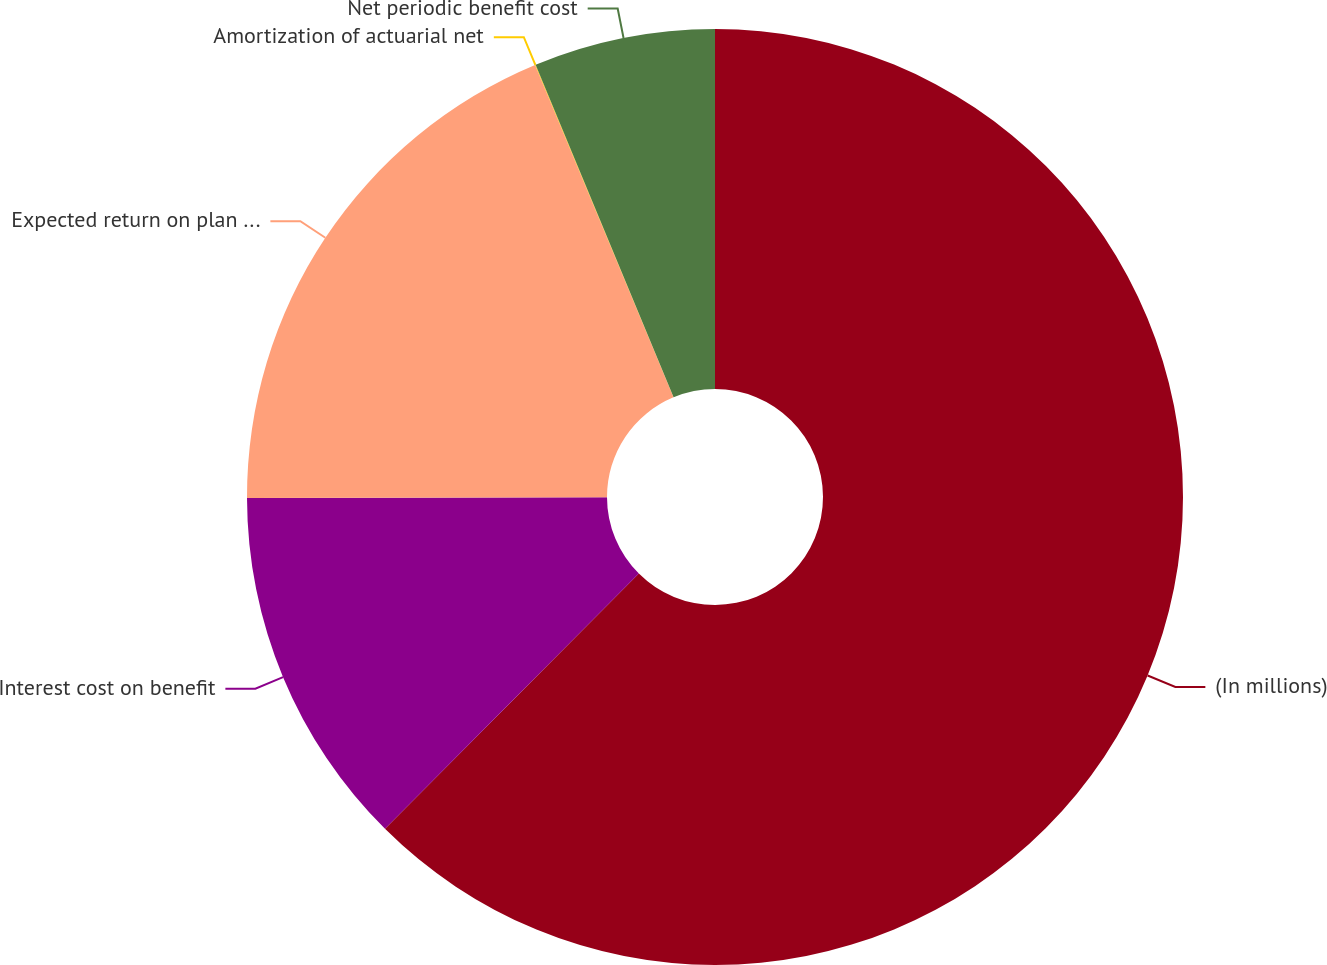Convert chart. <chart><loc_0><loc_0><loc_500><loc_500><pie_chart><fcel>(In millions)<fcel>Interest cost on benefit<fcel>Expected return on plan assets<fcel>Amortization of actuarial net<fcel>Net periodic benefit cost<nl><fcel>62.45%<fcel>12.51%<fcel>18.75%<fcel>0.02%<fcel>6.26%<nl></chart> 